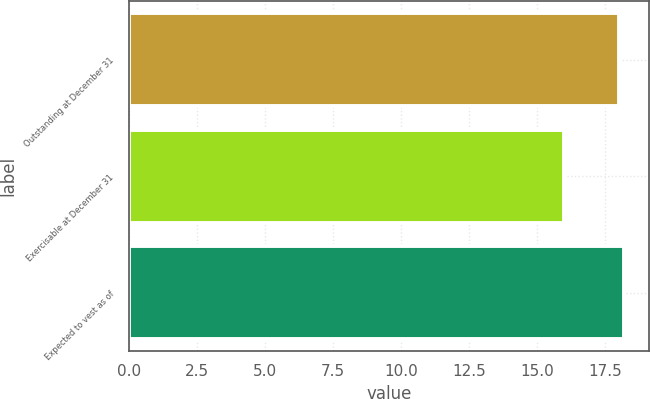Convert chart. <chart><loc_0><loc_0><loc_500><loc_500><bar_chart><fcel>Outstanding at December 31<fcel>Exercisable at December 31<fcel>Expected to vest as of<nl><fcel>18<fcel>16<fcel>18.2<nl></chart> 